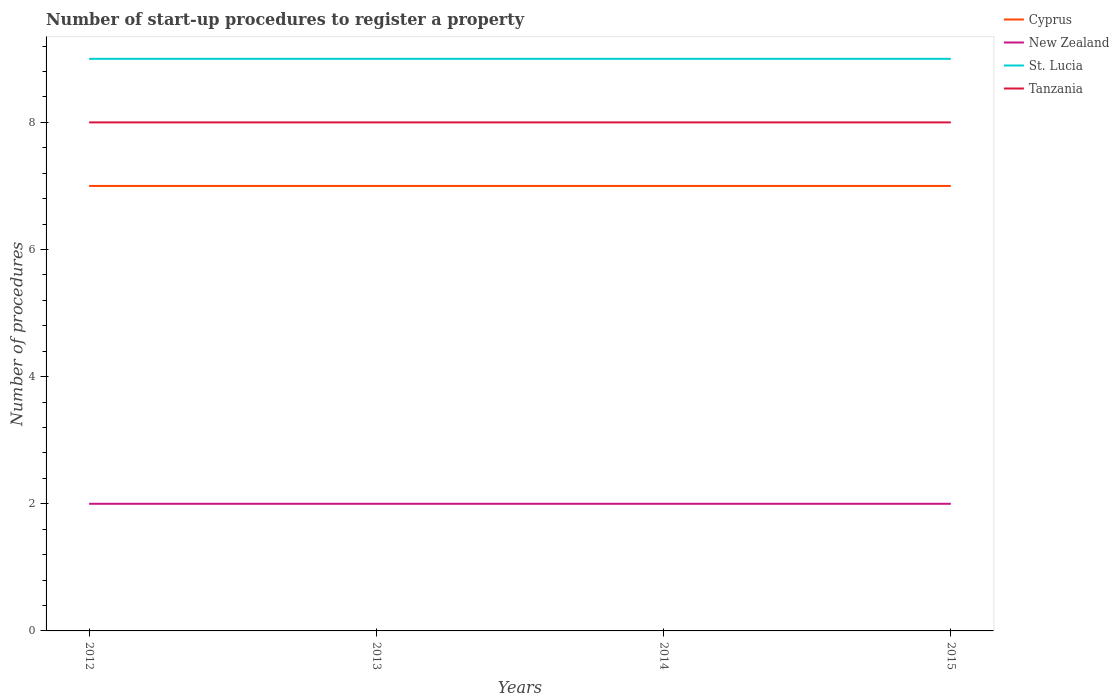Across all years, what is the maximum number of procedures required to register a property in New Zealand?
Your answer should be compact. 2. What is the total number of procedures required to register a property in St. Lucia in the graph?
Offer a terse response. 0. What is the difference between the highest and the second highest number of procedures required to register a property in St. Lucia?
Your answer should be very brief. 0. Is the number of procedures required to register a property in Tanzania strictly greater than the number of procedures required to register a property in St. Lucia over the years?
Your answer should be very brief. Yes. How many years are there in the graph?
Offer a very short reply. 4. Does the graph contain any zero values?
Offer a very short reply. No. Where does the legend appear in the graph?
Keep it short and to the point. Top right. How many legend labels are there?
Offer a terse response. 4. What is the title of the graph?
Make the answer very short. Number of start-up procedures to register a property. What is the label or title of the Y-axis?
Offer a very short reply. Number of procedures. What is the Number of procedures of Cyprus in 2012?
Your response must be concise. 7. What is the Number of procedures of New Zealand in 2012?
Keep it short and to the point. 2. What is the Number of procedures of St. Lucia in 2012?
Make the answer very short. 9. What is the Number of procedures in New Zealand in 2013?
Make the answer very short. 2. What is the Number of procedures in Cyprus in 2015?
Provide a succinct answer. 7. What is the Number of procedures in Tanzania in 2015?
Offer a terse response. 8. Across all years, what is the maximum Number of procedures of Tanzania?
Offer a terse response. 8. Across all years, what is the minimum Number of procedures of New Zealand?
Your answer should be compact. 2. What is the total Number of procedures of Cyprus in the graph?
Ensure brevity in your answer.  28. What is the total Number of procedures of New Zealand in the graph?
Your answer should be compact. 8. What is the difference between the Number of procedures of New Zealand in 2012 and that in 2013?
Ensure brevity in your answer.  0. What is the difference between the Number of procedures in St. Lucia in 2012 and that in 2013?
Your answer should be compact. 0. What is the difference between the Number of procedures of Cyprus in 2012 and that in 2014?
Your response must be concise. 0. What is the difference between the Number of procedures in New Zealand in 2012 and that in 2014?
Ensure brevity in your answer.  0. What is the difference between the Number of procedures in St. Lucia in 2012 and that in 2014?
Make the answer very short. 0. What is the difference between the Number of procedures of Tanzania in 2012 and that in 2014?
Provide a succinct answer. 0. What is the difference between the Number of procedures in New Zealand in 2012 and that in 2015?
Offer a terse response. 0. What is the difference between the Number of procedures in Tanzania in 2012 and that in 2015?
Provide a short and direct response. 0. What is the difference between the Number of procedures of Cyprus in 2013 and that in 2014?
Give a very brief answer. 0. What is the difference between the Number of procedures in Tanzania in 2013 and that in 2014?
Keep it short and to the point. 0. What is the difference between the Number of procedures in Cyprus in 2013 and that in 2015?
Make the answer very short. 0. What is the difference between the Number of procedures in Cyprus in 2014 and that in 2015?
Offer a terse response. 0. What is the difference between the Number of procedures of New Zealand in 2014 and that in 2015?
Keep it short and to the point. 0. What is the difference between the Number of procedures of St. Lucia in 2014 and that in 2015?
Make the answer very short. 0. What is the difference between the Number of procedures of Tanzania in 2014 and that in 2015?
Make the answer very short. 0. What is the difference between the Number of procedures of New Zealand in 2012 and the Number of procedures of St. Lucia in 2013?
Offer a terse response. -7. What is the difference between the Number of procedures of Cyprus in 2012 and the Number of procedures of New Zealand in 2014?
Keep it short and to the point. 5. What is the difference between the Number of procedures in Cyprus in 2012 and the Number of procedures in Tanzania in 2014?
Provide a succinct answer. -1. What is the difference between the Number of procedures in New Zealand in 2012 and the Number of procedures in Tanzania in 2014?
Keep it short and to the point. -6. What is the difference between the Number of procedures of St. Lucia in 2012 and the Number of procedures of Tanzania in 2014?
Keep it short and to the point. 1. What is the difference between the Number of procedures in Cyprus in 2012 and the Number of procedures in New Zealand in 2015?
Your answer should be very brief. 5. What is the difference between the Number of procedures in Cyprus in 2012 and the Number of procedures in St. Lucia in 2015?
Offer a very short reply. -2. What is the difference between the Number of procedures of Cyprus in 2012 and the Number of procedures of Tanzania in 2015?
Your answer should be very brief. -1. What is the difference between the Number of procedures of St. Lucia in 2012 and the Number of procedures of Tanzania in 2015?
Your answer should be very brief. 1. What is the difference between the Number of procedures in Cyprus in 2013 and the Number of procedures in New Zealand in 2014?
Make the answer very short. 5. What is the difference between the Number of procedures of Cyprus in 2013 and the Number of procedures of St. Lucia in 2014?
Provide a succinct answer. -2. What is the difference between the Number of procedures in Cyprus in 2013 and the Number of procedures in Tanzania in 2014?
Your response must be concise. -1. What is the difference between the Number of procedures of St. Lucia in 2013 and the Number of procedures of Tanzania in 2014?
Keep it short and to the point. 1. What is the difference between the Number of procedures of Cyprus in 2013 and the Number of procedures of Tanzania in 2015?
Your answer should be compact. -1. What is the difference between the Number of procedures of New Zealand in 2013 and the Number of procedures of St. Lucia in 2015?
Give a very brief answer. -7. What is the difference between the Number of procedures in New Zealand in 2014 and the Number of procedures in Tanzania in 2015?
Provide a succinct answer. -6. What is the average Number of procedures in Cyprus per year?
Ensure brevity in your answer.  7. What is the average Number of procedures in New Zealand per year?
Ensure brevity in your answer.  2. What is the average Number of procedures of St. Lucia per year?
Make the answer very short. 9. What is the average Number of procedures in Tanzania per year?
Make the answer very short. 8. In the year 2012, what is the difference between the Number of procedures in Cyprus and Number of procedures in New Zealand?
Ensure brevity in your answer.  5. In the year 2012, what is the difference between the Number of procedures in Cyprus and Number of procedures in St. Lucia?
Your answer should be very brief. -2. In the year 2012, what is the difference between the Number of procedures of Cyprus and Number of procedures of Tanzania?
Offer a very short reply. -1. In the year 2013, what is the difference between the Number of procedures of Cyprus and Number of procedures of St. Lucia?
Your answer should be very brief. -2. In the year 2014, what is the difference between the Number of procedures in Cyprus and Number of procedures in St. Lucia?
Your answer should be very brief. -2. In the year 2014, what is the difference between the Number of procedures of New Zealand and Number of procedures of Tanzania?
Ensure brevity in your answer.  -6. In the year 2015, what is the difference between the Number of procedures in New Zealand and Number of procedures in St. Lucia?
Offer a terse response. -7. In the year 2015, what is the difference between the Number of procedures of St. Lucia and Number of procedures of Tanzania?
Provide a short and direct response. 1. What is the ratio of the Number of procedures in Tanzania in 2012 to that in 2013?
Your answer should be compact. 1. What is the ratio of the Number of procedures of Cyprus in 2012 to that in 2014?
Your answer should be compact. 1. What is the ratio of the Number of procedures in New Zealand in 2012 to that in 2014?
Ensure brevity in your answer.  1. What is the ratio of the Number of procedures of Cyprus in 2012 to that in 2015?
Provide a succinct answer. 1. What is the ratio of the Number of procedures of New Zealand in 2012 to that in 2015?
Keep it short and to the point. 1. What is the ratio of the Number of procedures of St. Lucia in 2012 to that in 2015?
Your answer should be very brief. 1. What is the ratio of the Number of procedures in Tanzania in 2012 to that in 2015?
Give a very brief answer. 1. What is the ratio of the Number of procedures in St. Lucia in 2013 to that in 2014?
Provide a short and direct response. 1. What is the ratio of the Number of procedures of Cyprus in 2013 to that in 2015?
Offer a terse response. 1. What is the difference between the highest and the second highest Number of procedures of Cyprus?
Offer a very short reply. 0. What is the difference between the highest and the second highest Number of procedures of St. Lucia?
Make the answer very short. 0. What is the difference between the highest and the second highest Number of procedures in Tanzania?
Give a very brief answer. 0. What is the difference between the highest and the lowest Number of procedures of Cyprus?
Provide a short and direct response. 0. What is the difference between the highest and the lowest Number of procedures of St. Lucia?
Offer a very short reply. 0. 